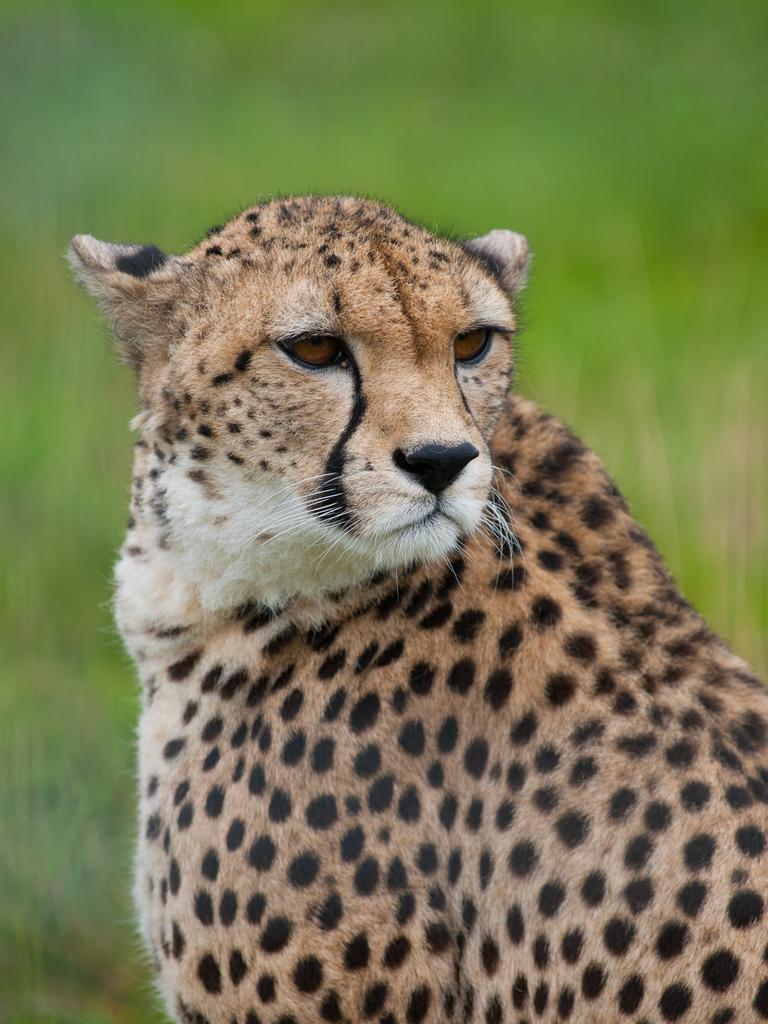Can you describe this image briefly? In this image we can see a leopard. 